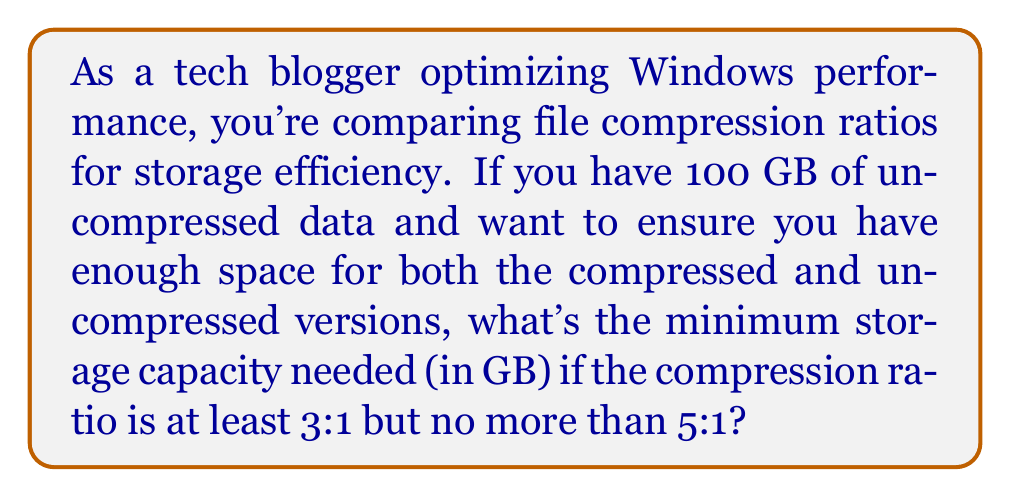Provide a solution to this math problem. Let's approach this step-by-step:

1) We start with 100 GB of uncompressed data.

2) The compression ratio range is 3:1 to 5:1. This means:
   - At best (5:1), the compressed data will take up 1/5 of the original size.
   - At worst (3:1), the compressed data will take up 1/3 of the original size.

3) To calculate the range of compressed data size:
   - Minimum size: $100 \text{ GB} \times \frac{1}{5} = 20 \text{ GB}$
   - Maximum size: $100 \text{ GB} \times \frac{1}{3} \approx 33.33 \text{ GB}$

4) We need to store both the uncompressed (100 GB) and compressed versions.

5) To ensure we have enough space for both, we need to account for the worst-case scenario, which is the larger compressed size:

   $100 \text{ GB} + 33.33 \text{ GB} = 133.33 \text{ GB}$

6) Since storage is typically sold in whole numbers, we round up to the nearest GB.

Therefore, the minimum storage capacity needed is 134 GB.
Answer: 134 GB 